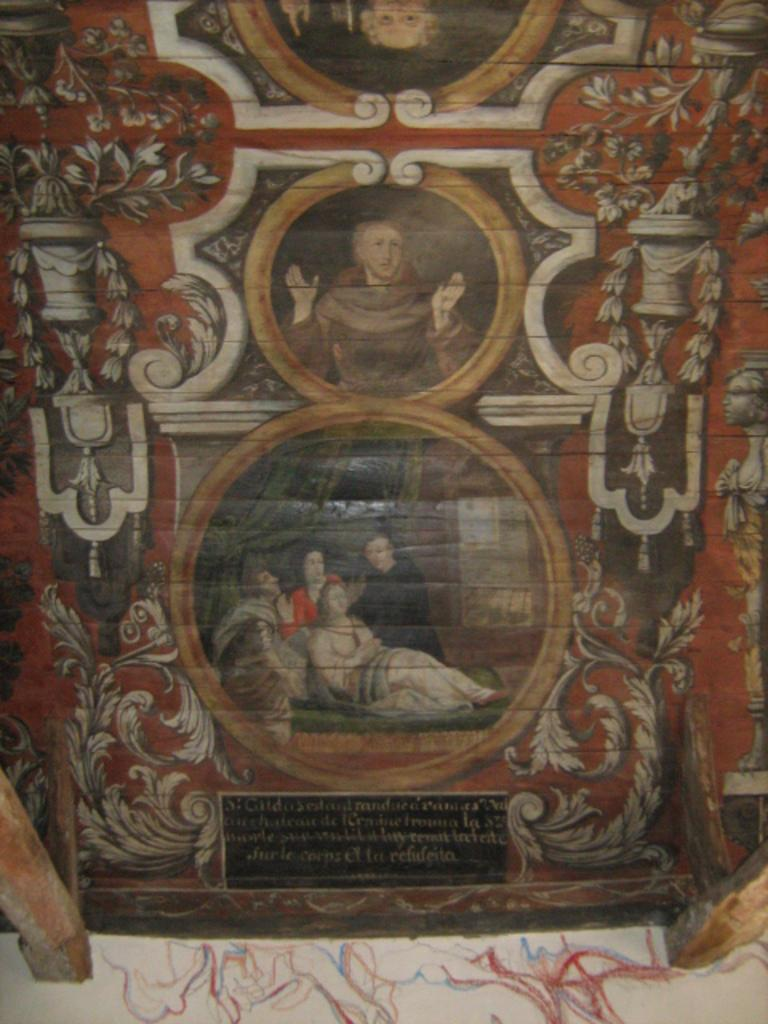What is on the board in the image? There is a painting, images, and writing on the board. Can you describe the painting on the board? Unfortunately, the details of the painting cannot be determined from the image alone. What type of images are on the board? The images on the board are not specified in the facts provided. What does the writing on the board say? The content of the writing on the board cannot be determined from the image alone. Where is the bucket located in the image? There is no bucket present in the image. What type of wine is being served in the image? There is no wine present in the image. 